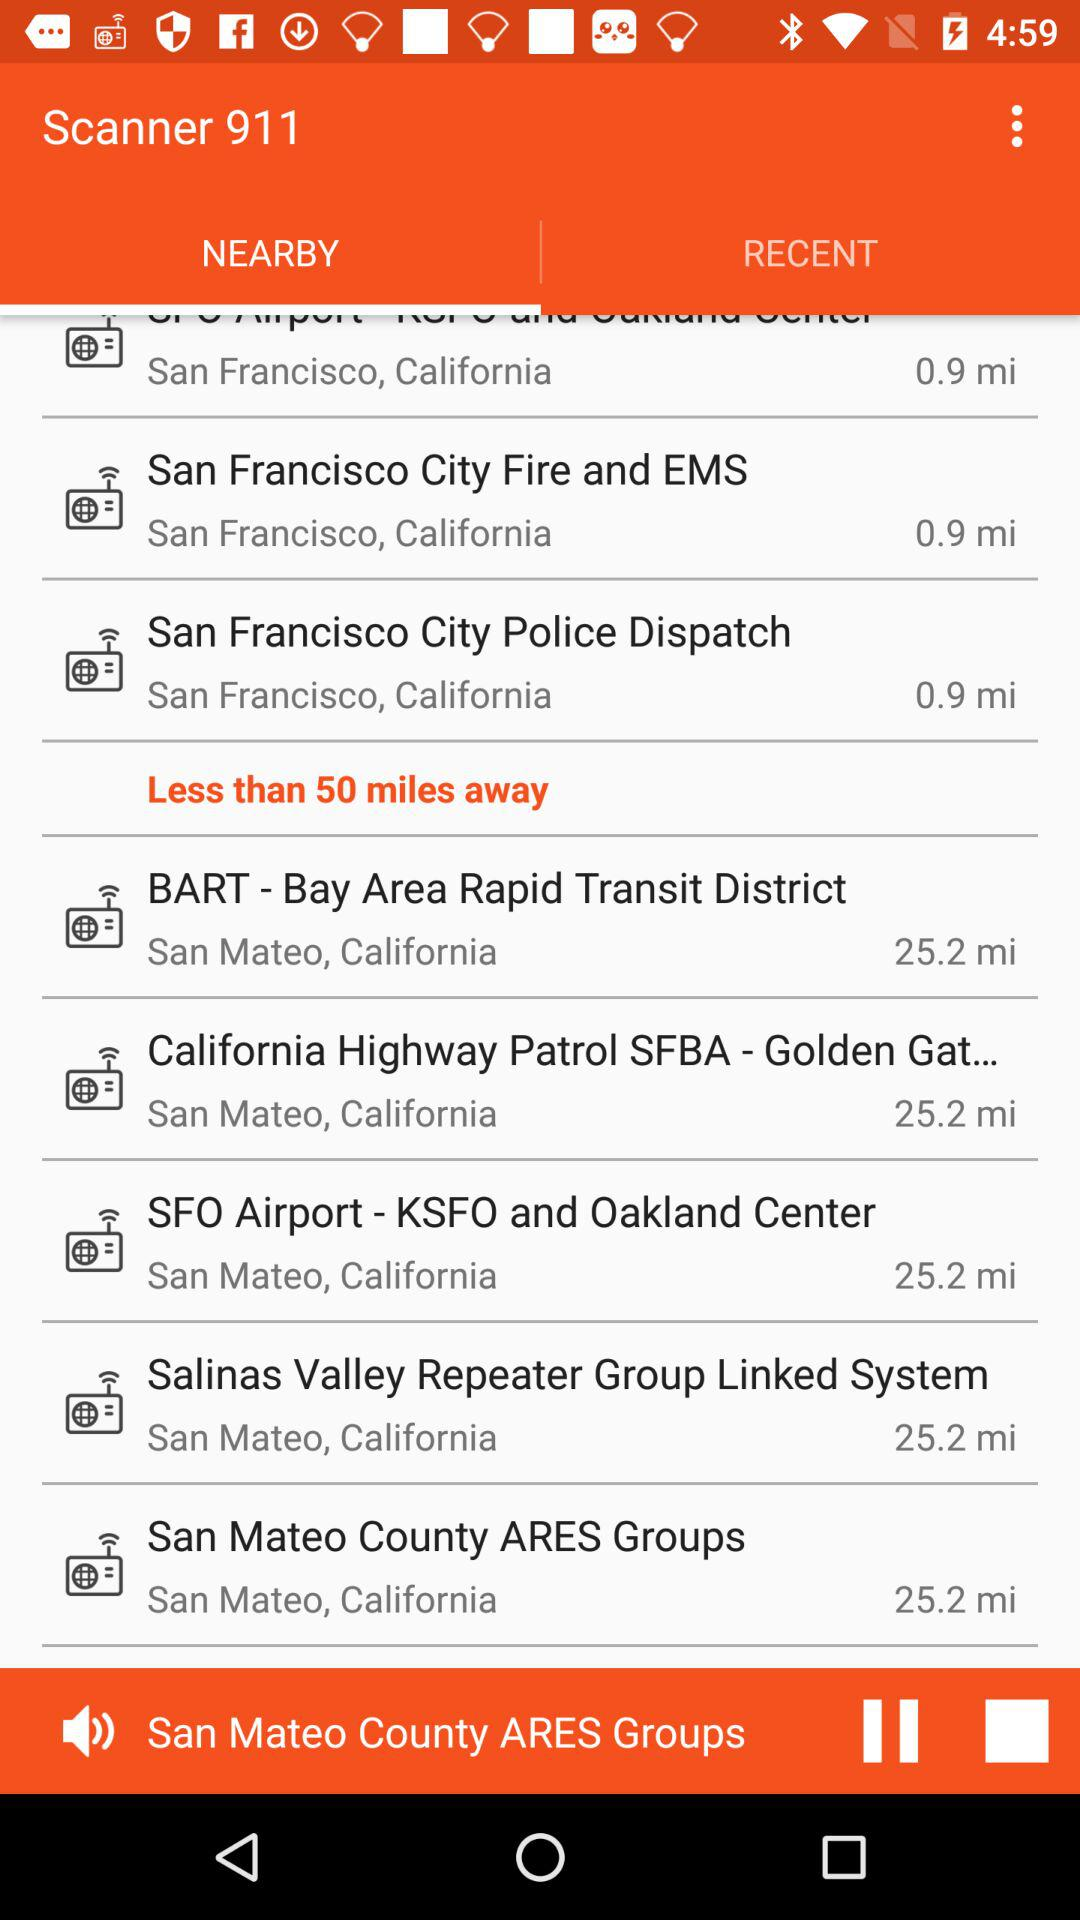How far away are SFO airport-KSFO and Oakland Center? The SFO airport-KSFO and Oakland Center are 25.2 mi away. 